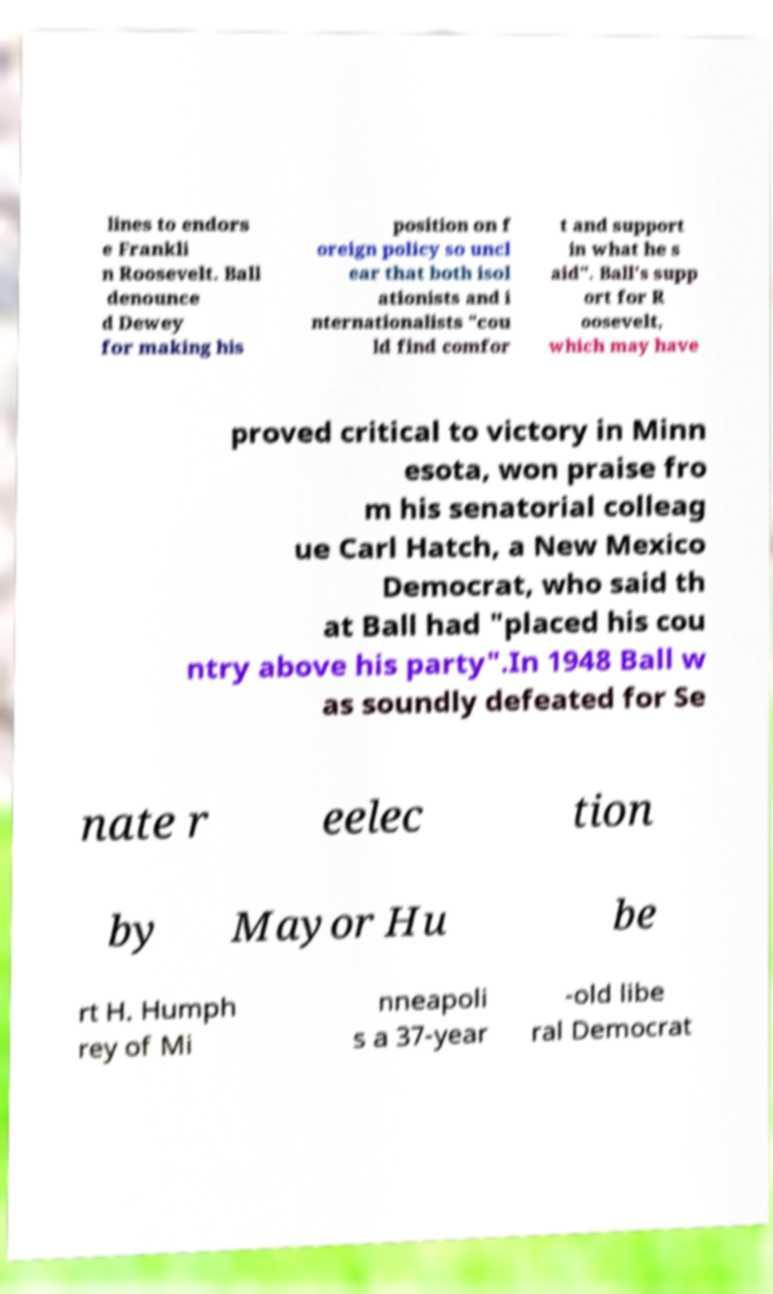There's text embedded in this image that I need extracted. Can you transcribe it verbatim? lines to endors e Frankli n Roosevelt. Ball denounce d Dewey for making his position on f oreign policy so uncl ear that both isol ationists and i nternationalists "cou ld find comfor t and support in what he s aid". Ball's supp ort for R oosevelt, which may have proved critical to victory in Minn esota, won praise fro m his senatorial colleag ue Carl Hatch, a New Mexico Democrat, who said th at Ball had "placed his cou ntry above his party".In 1948 Ball w as soundly defeated for Se nate r eelec tion by Mayor Hu be rt H. Humph rey of Mi nneapoli s a 37-year -old libe ral Democrat 